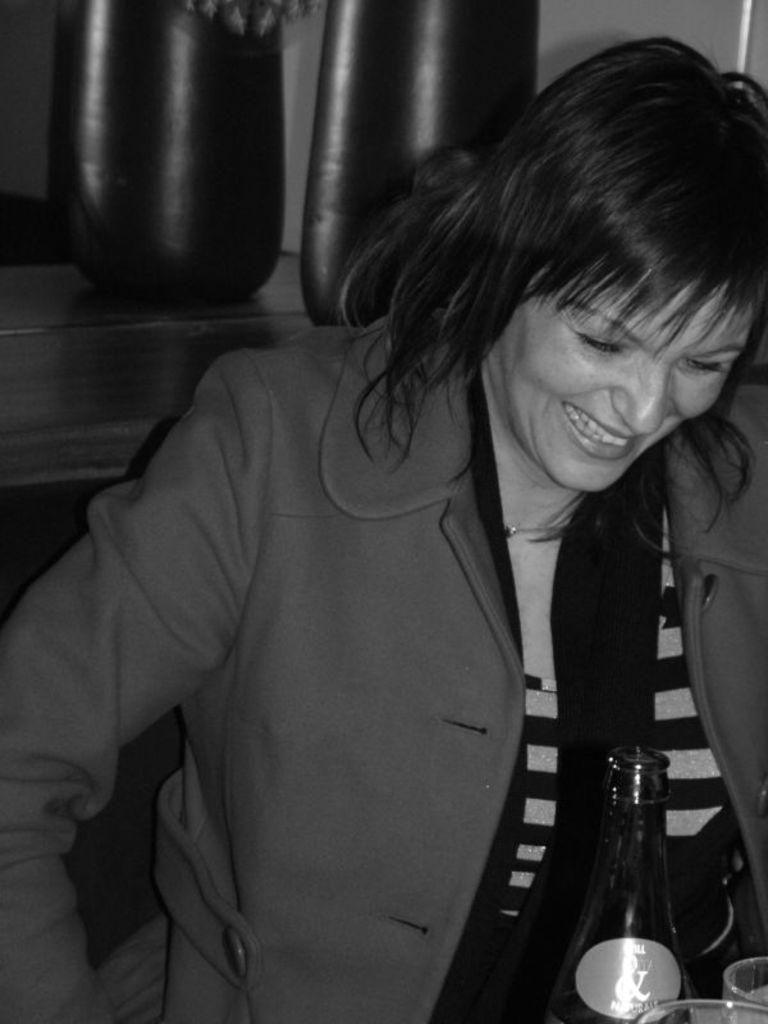Who or what is the main subject in the image? There is a person in the image. What objects are in front of the person? There is a bottle and glasses in front of the person. What is behind the person? There is a table at the back of the person. Can you describe the object on the table? There appears to be an object on the table, but its specific details are not clear from the provided facts. What type of apparel is the person wearing in the image? The provided facts do not mention any details about the person's apparel, so we cannot determine what type of clothing they are wearing. 